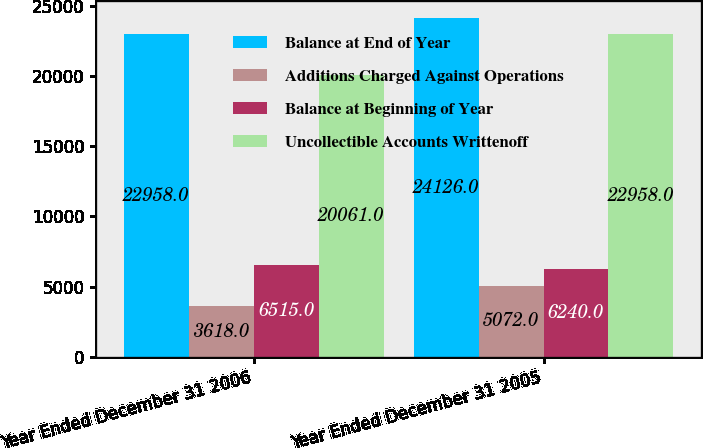Convert chart. <chart><loc_0><loc_0><loc_500><loc_500><stacked_bar_chart><ecel><fcel>Year Ended December 31 2006<fcel>Year Ended December 31 2005<nl><fcel>Balance at End of Year<fcel>22958<fcel>24126<nl><fcel>Additions Charged Against Operations<fcel>3618<fcel>5072<nl><fcel>Balance at Beginning of Year<fcel>6515<fcel>6240<nl><fcel>Uncollectible Accounts Writtenoff<fcel>20061<fcel>22958<nl></chart> 